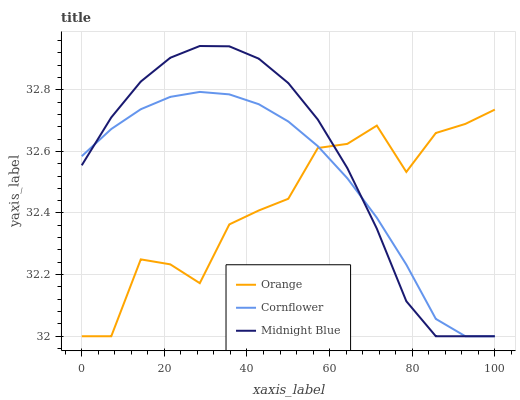Does Cornflower have the minimum area under the curve?
Answer yes or no. No. Does Cornflower have the maximum area under the curve?
Answer yes or no. No. Is Midnight Blue the smoothest?
Answer yes or no. No. Is Midnight Blue the roughest?
Answer yes or no. No. Does Cornflower have the highest value?
Answer yes or no. No. 